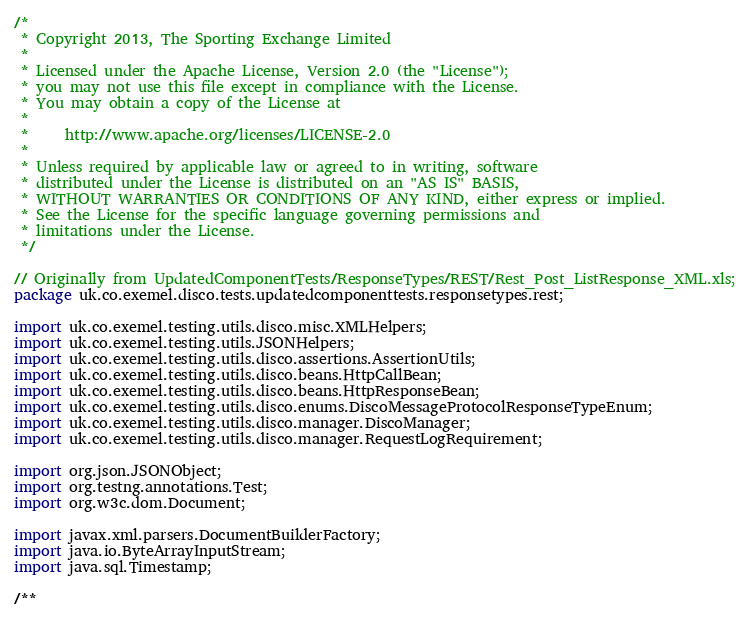<code> <loc_0><loc_0><loc_500><loc_500><_Java_>/*
 * Copyright 2013, The Sporting Exchange Limited
 *
 * Licensed under the Apache License, Version 2.0 (the "License");
 * you may not use this file except in compliance with the License.
 * You may obtain a copy of the License at
 *
 *     http://www.apache.org/licenses/LICENSE-2.0
 *
 * Unless required by applicable law or agreed to in writing, software
 * distributed under the License is distributed on an "AS IS" BASIS,
 * WITHOUT WARRANTIES OR CONDITIONS OF ANY KIND, either express or implied.
 * See the License for the specific language governing permissions and
 * limitations under the License.
 */

// Originally from UpdatedComponentTests/ResponseTypes/REST/Rest_Post_ListResponse_XML.xls;
package uk.co.exemel.disco.tests.updatedcomponenttests.responsetypes.rest;

import uk.co.exemel.testing.utils.disco.misc.XMLHelpers;
import uk.co.exemel.testing.utils.JSONHelpers;
import uk.co.exemel.testing.utils.disco.assertions.AssertionUtils;
import uk.co.exemel.testing.utils.disco.beans.HttpCallBean;
import uk.co.exemel.testing.utils.disco.beans.HttpResponseBean;
import uk.co.exemel.testing.utils.disco.enums.DiscoMessageProtocolResponseTypeEnum;
import uk.co.exemel.testing.utils.disco.manager.DiscoManager;
import uk.co.exemel.testing.utils.disco.manager.RequestLogRequirement;

import org.json.JSONObject;
import org.testng.annotations.Test;
import org.w3c.dom.Document;

import javax.xml.parsers.DocumentBuilderFactory;
import java.io.ByteArrayInputStream;
import java.sql.Timestamp;

/**</code> 